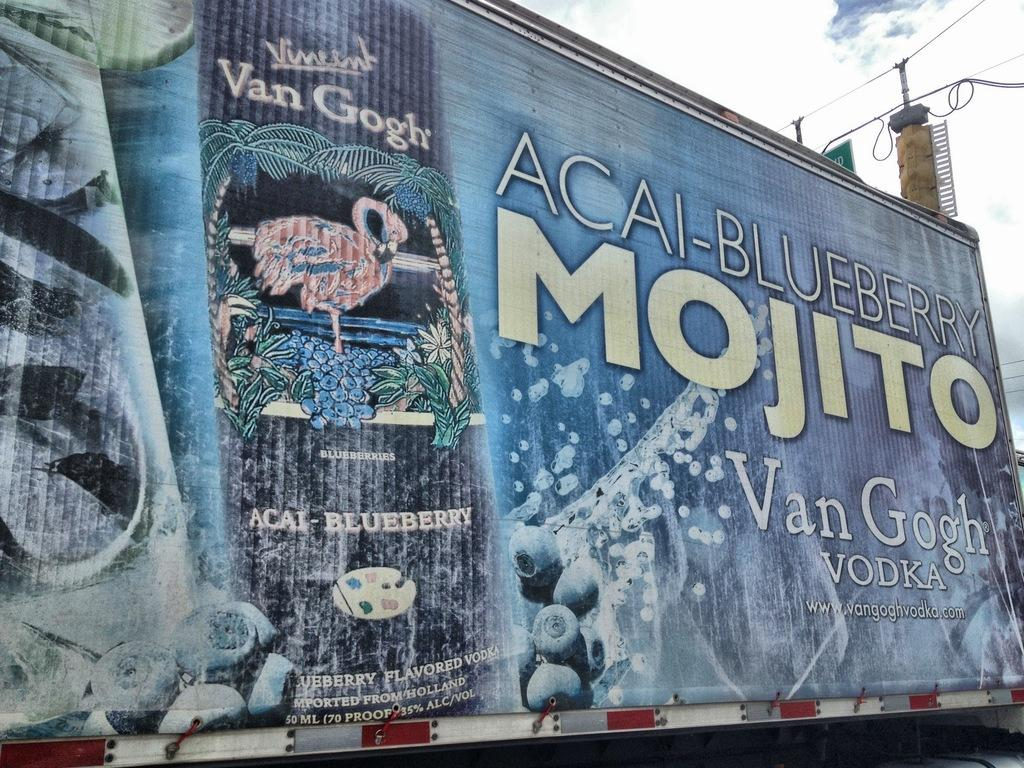Provide a one-sentence caption for the provided image. The truck is painted with Van Gogh Vodka ads. 